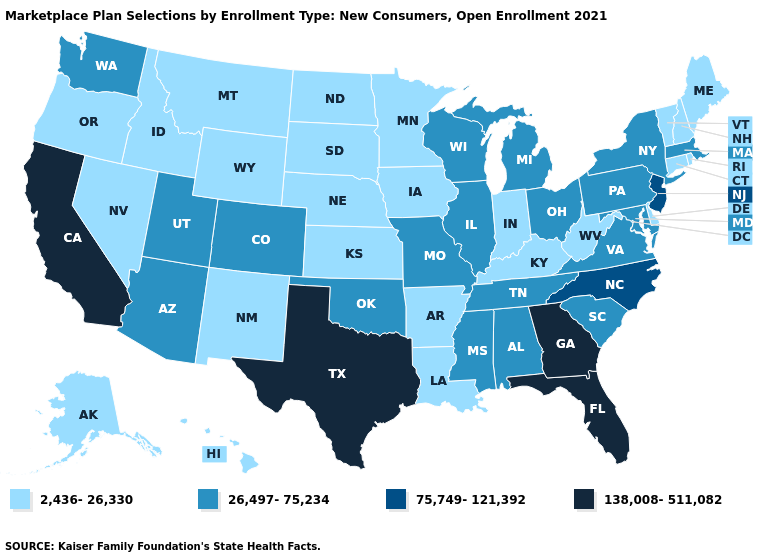Which states have the lowest value in the South?
Be succinct. Arkansas, Delaware, Kentucky, Louisiana, West Virginia. Name the states that have a value in the range 2,436-26,330?
Give a very brief answer. Alaska, Arkansas, Connecticut, Delaware, Hawaii, Idaho, Indiana, Iowa, Kansas, Kentucky, Louisiana, Maine, Minnesota, Montana, Nebraska, Nevada, New Hampshire, New Mexico, North Dakota, Oregon, Rhode Island, South Dakota, Vermont, West Virginia, Wyoming. Does the map have missing data?
Give a very brief answer. No. Among the states that border Iowa , which have the lowest value?
Be succinct. Minnesota, Nebraska, South Dakota. Among the states that border Vermont , which have the lowest value?
Write a very short answer. New Hampshire. Is the legend a continuous bar?
Give a very brief answer. No. How many symbols are there in the legend?
Keep it brief. 4. Name the states that have a value in the range 26,497-75,234?
Write a very short answer. Alabama, Arizona, Colorado, Illinois, Maryland, Massachusetts, Michigan, Mississippi, Missouri, New York, Ohio, Oklahoma, Pennsylvania, South Carolina, Tennessee, Utah, Virginia, Washington, Wisconsin. What is the value of Minnesota?
Write a very short answer. 2,436-26,330. Does Wisconsin have the lowest value in the USA?
Answer briefly. No. What is the value of Michigan?
Quick response, please. 26,497-75,234. Does Pennsylvania have the highest value in the Northeast?
Quick response, please. No. Among the states that border Maine , which have the lowest value?
Answer briefly. New Hampshire. What is the value of Hawaii?
Give a very brief answer. 2,436-26,330. Does Colorado have the lowest value in the West?
Give a very brief answer. No. 